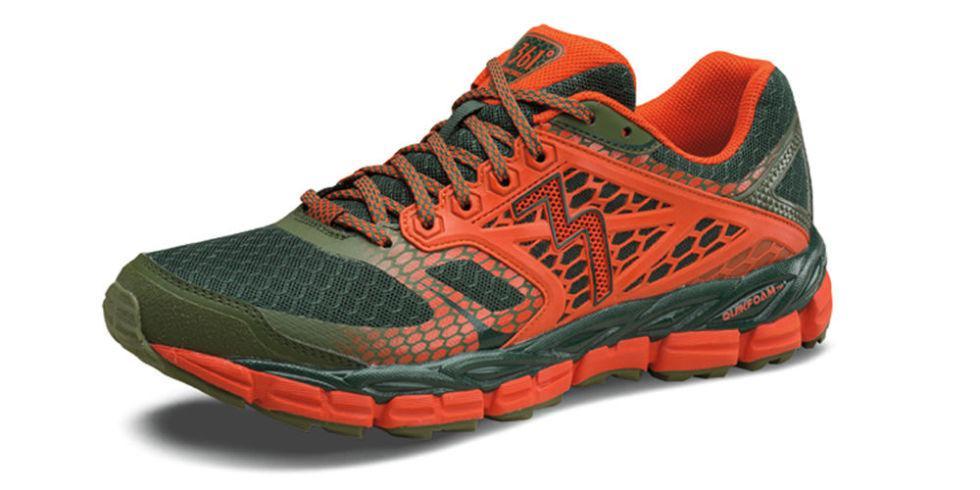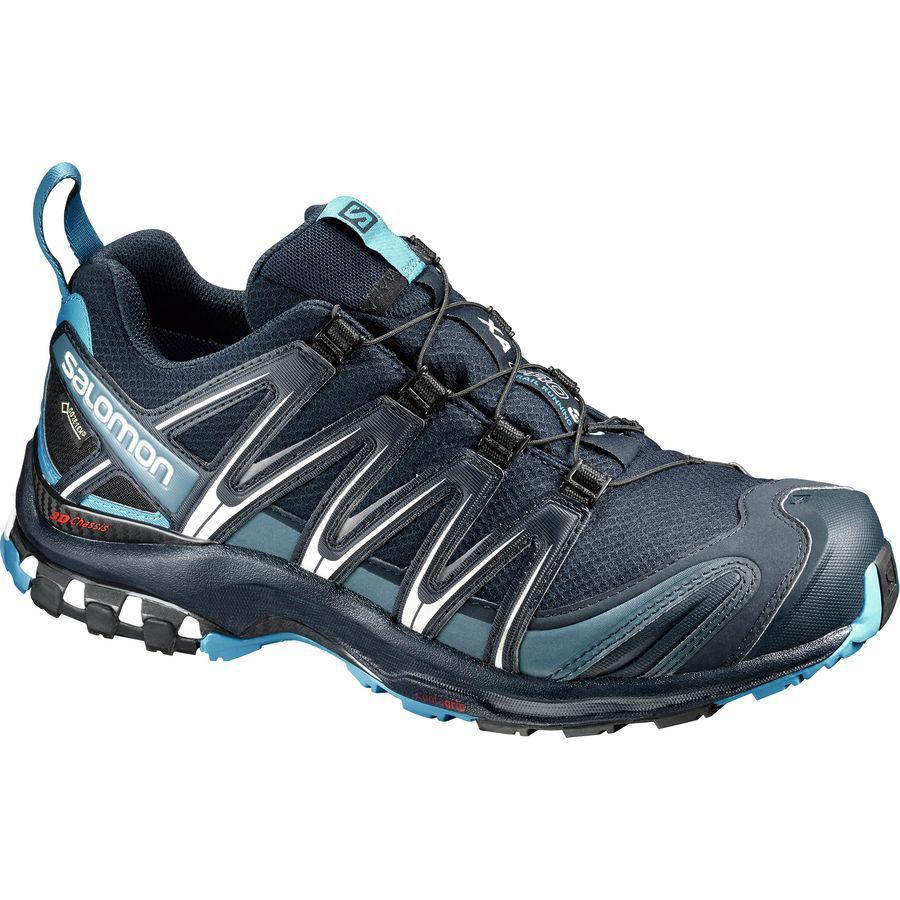The first image is the image on the left, the second image is the image on the right. Evaluate the accuracy of this statement regarding the images: "Left and right images each contain a single shoe with an athletic tread sole, one shoe has a zig-zag design element, and the shoe on the right has a loop at the heel.". Is it true? Answer yes or no. Yes. 